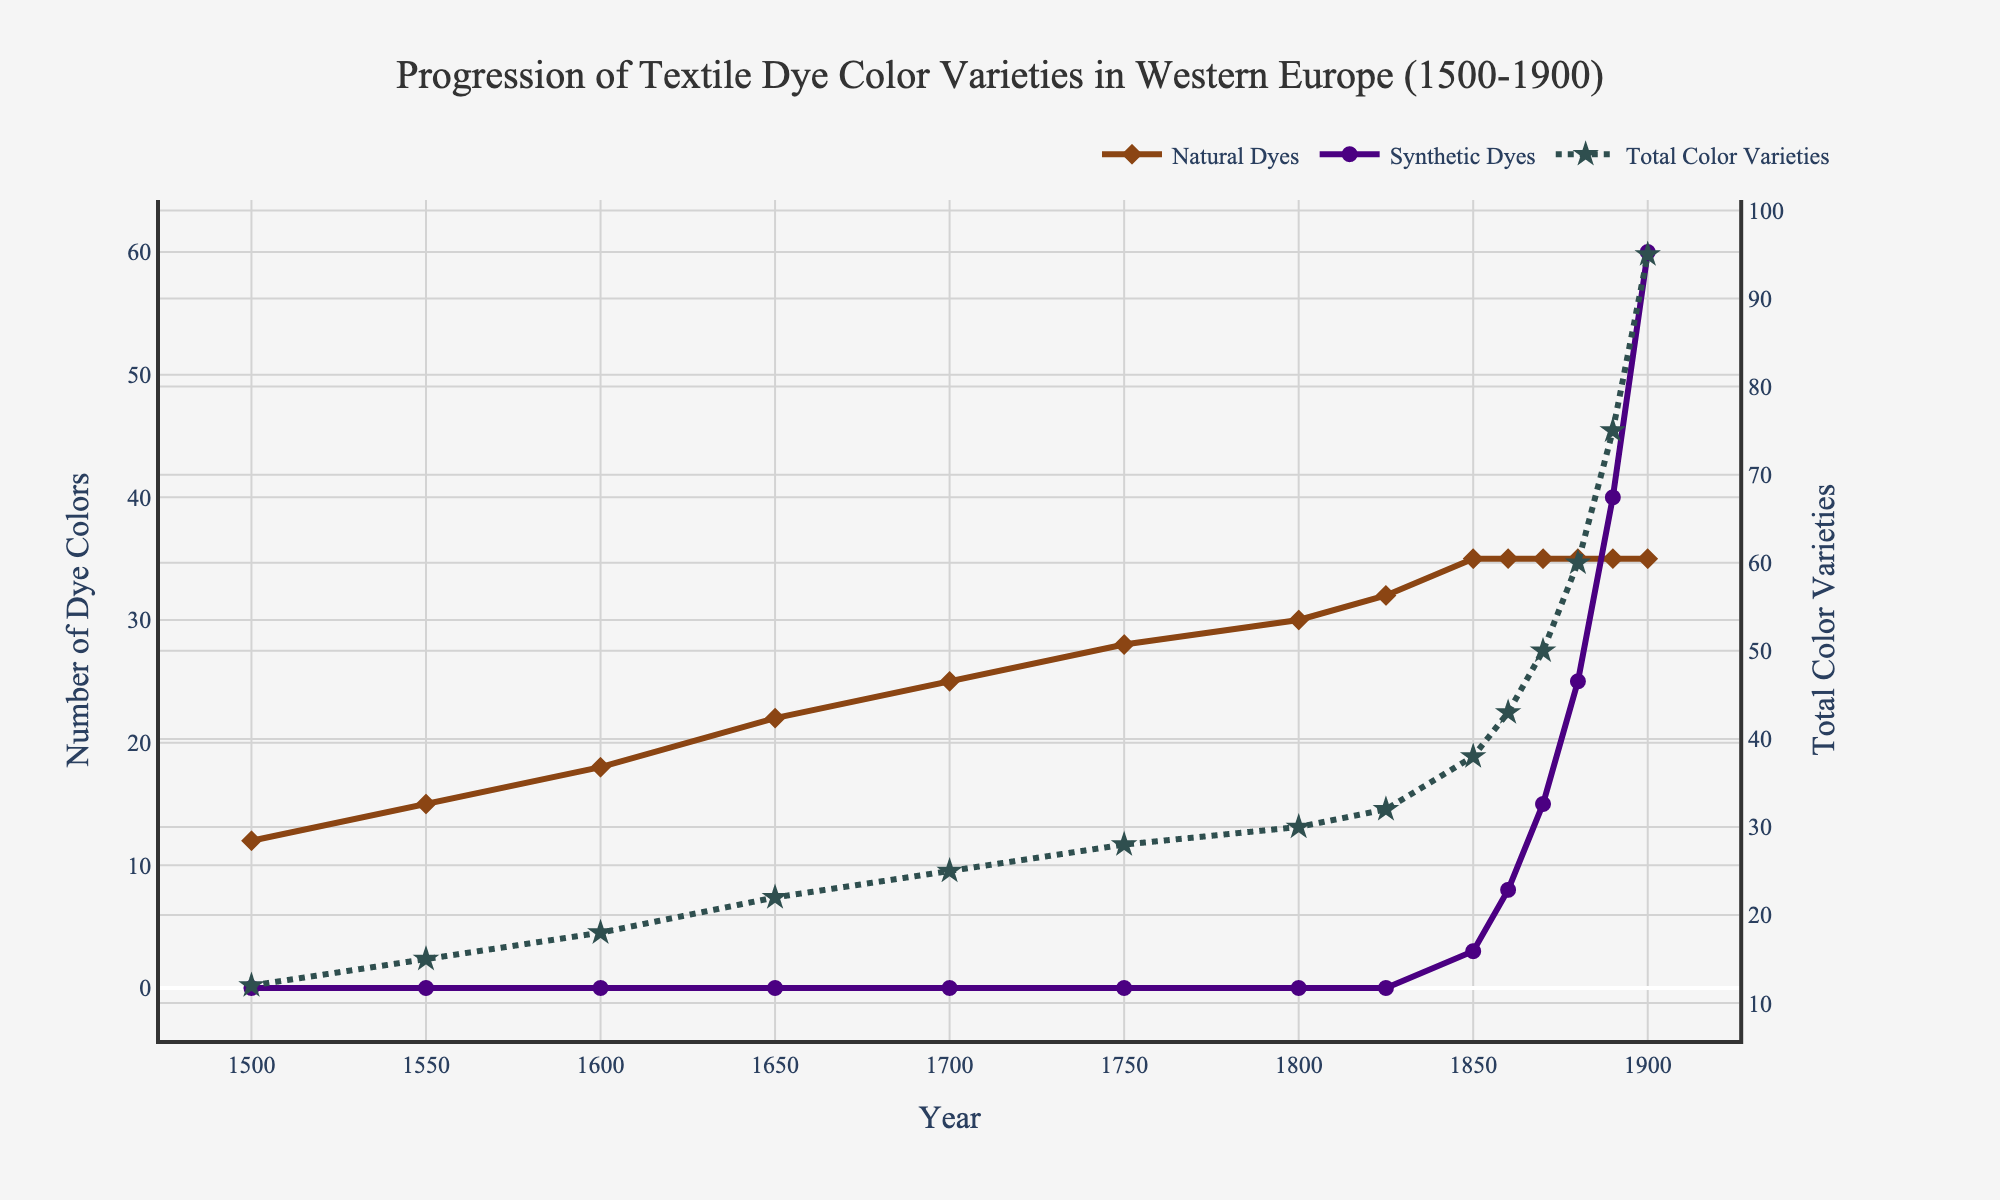What was the total number of color varieties available in 1850? To find this, look at the data points in the Total Color Varieties line for the year 1850. The graph shows a dot hovering around 38.
Answer: 38 In which year did synthetic dyes first appear? Check the Synthetic Dyes line graph to see when it first deviated from zero. The year is 1850.
Answer: 1850 Compare the number of natural dye colors available in 1700 and 1750. Which year had more? By examining the Natural Dyes line, one can see that the quantity increased from 25 in 1700 to 28 in 1750.
Answer: 1750 How many dye color varieties were added from 1800 to 1900? Look at Total Color Varieties in the years 1800 and 1900. The difference between 95 (1900) and 30 (1800) is 65.
Answer: 65 What were the total color varieties available in 1870, and how much did synthetic dyes contribute to it? Check the Total Color Varieties and Synthetic Dyes lines for 1870. Total is 50; synthetic dyes contributed 15.
Answer: Total: 50, Synthetic: 15 What is the trend in natural dye color varieties between 1500 and 1900? The Natural Dyes line shows a steady increase until 1825 where it plateaus at 35 colors and remains constant afterward.
Answer: Steadily increases until plateau By how much did the total color varieties increase from 1850 to 1880? The Total Color Varieties line shows an increase from 38 in 1850 to 60 in 1880. The difference is 22.
Answer: 22 Which had a higher growth rate between 1850 and 1900: natural dyes or synthetic dyes? The Synthetic Dyes line increased from 3 to 60 (57 dyes) while the Natural Dyes line remained at 35, showing no growth from 1850 onwards.
Answer: Synthetic dyes How many total dye color varieties were there in 1825 compared to 1870? Look at the Total Color Varieties line. 1825 had 32 and 1870 had 50.
Answer: 1825: 32, 1870: 50 Between which decades did synthetic dyes see the largest increase in color varieties? The largest increase in the Synthetic Dyes line occurs between 1880 (25 colors) and 1890 (40 colors), indicating an addition of 15.
Answer: 1880-1890 